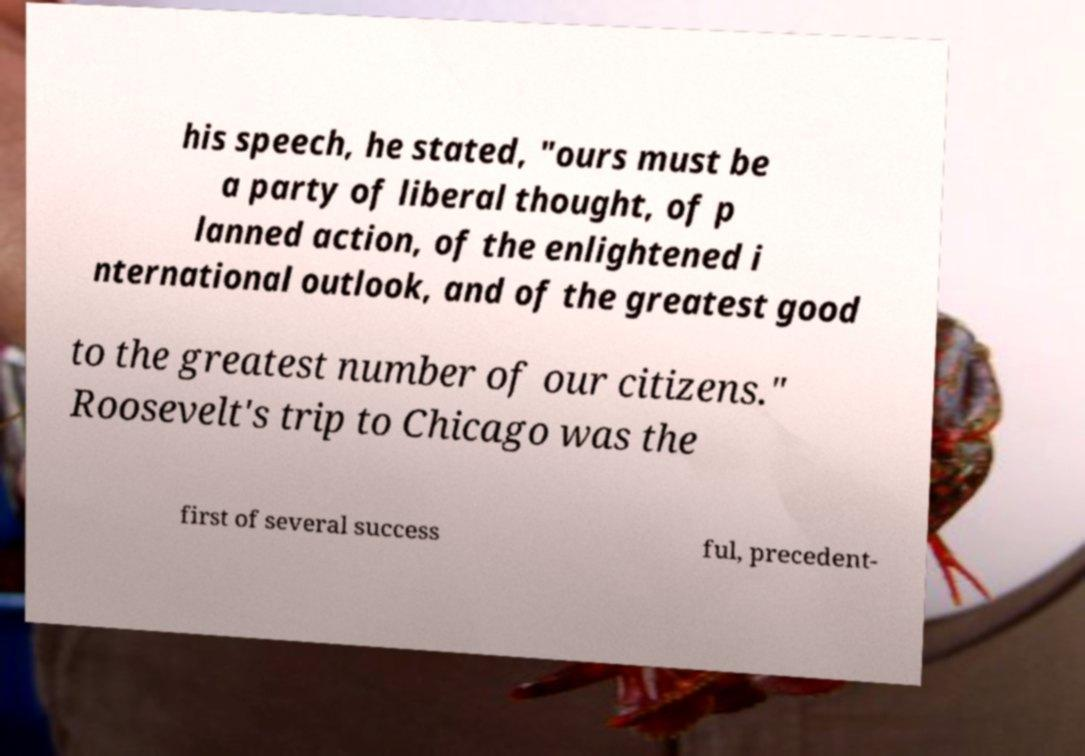Could you extract and type out the text from this image? his speech, he stated, "ours must be a party of liberal thought, of p lanned action, of the enlightened i nternational outlook, and of the greatest good to the greatest number of our citizens." Roosevelt's trip to Chicago was the first of several success ful, precedent- 